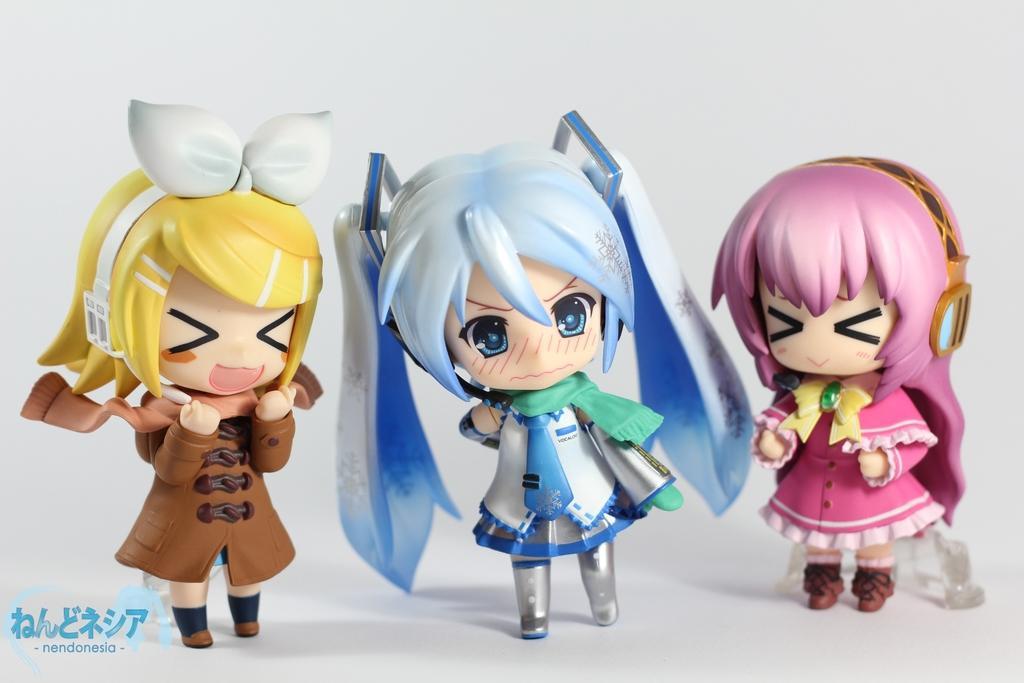How would you summarize this image in a sentence or two? In this image, we can see some toys. 